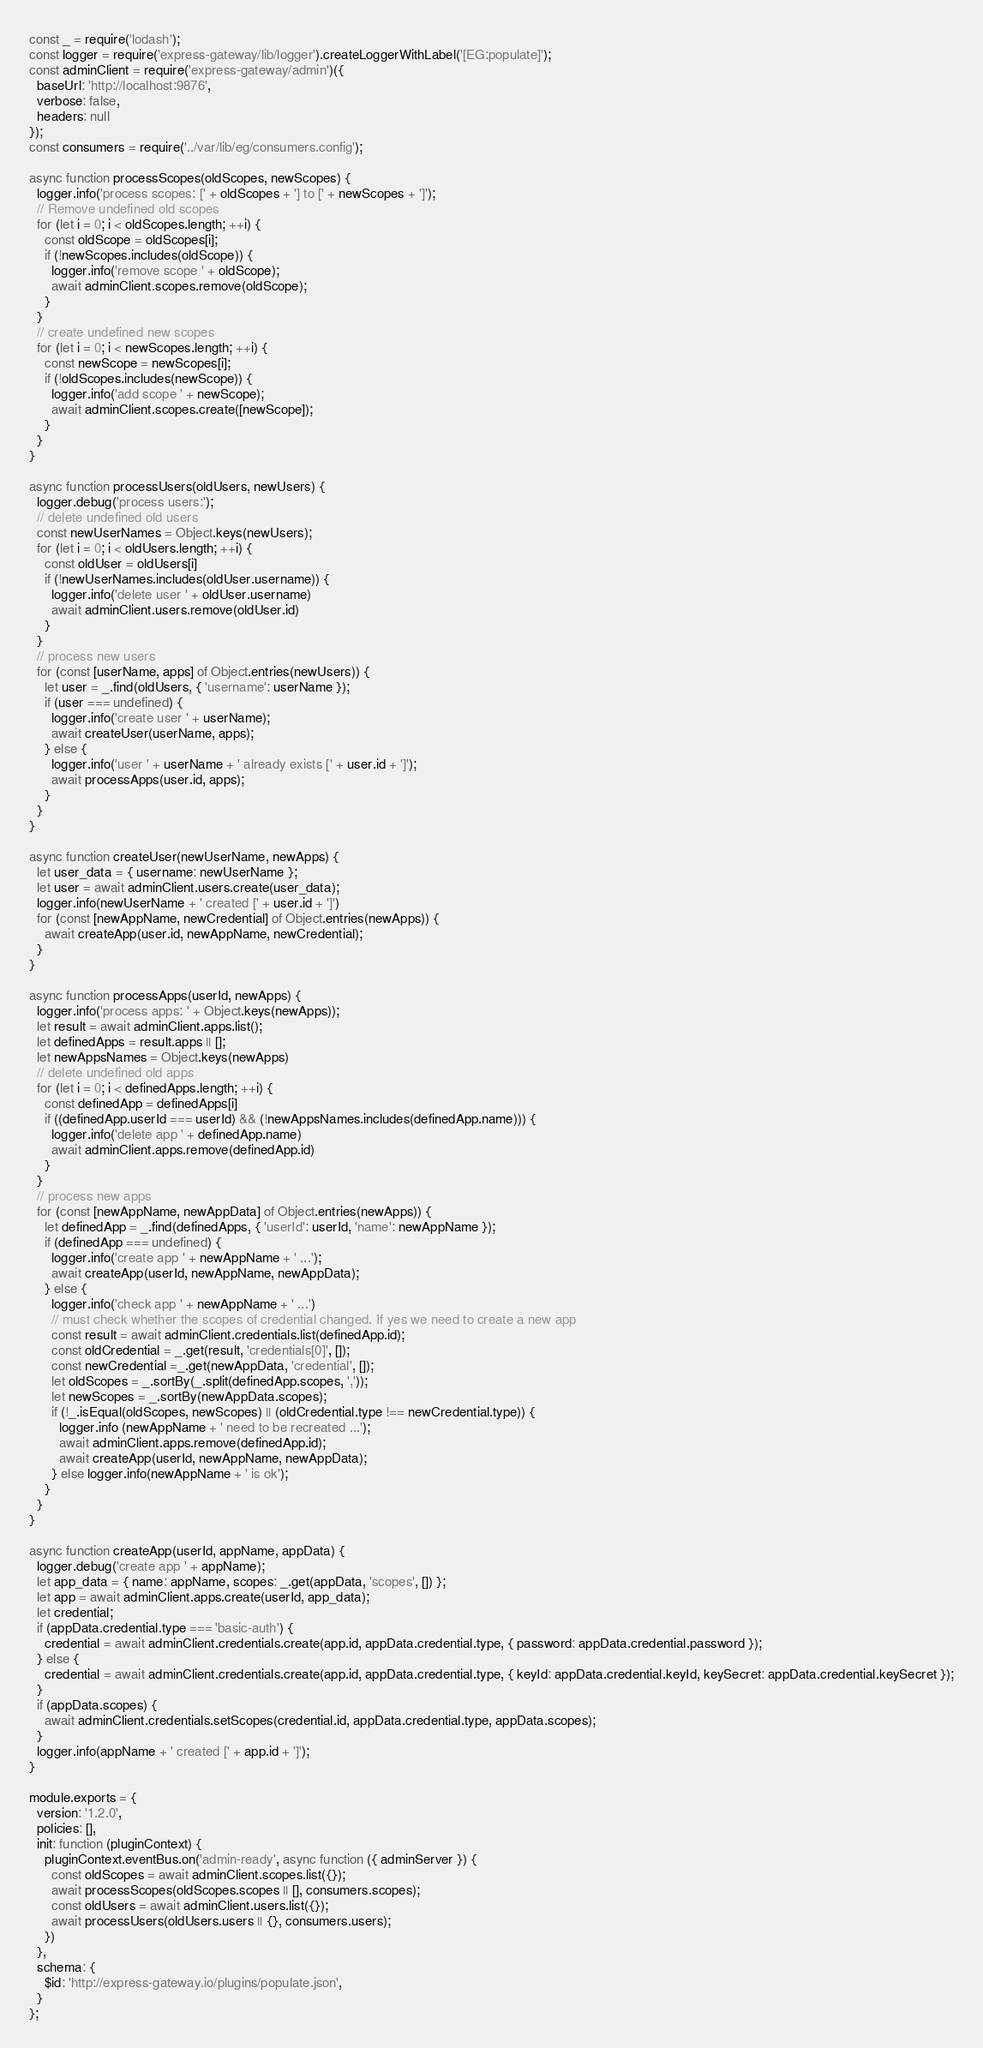<code> <loc_0><loc_0><loc_500><loc_500><_JavaScript_>const _ = require('lodash');
const logger = require('express-gateway/lib/logger').createLoggerWithLabel('[EG:populate]');
const adminClient = require('express-gateway/admin')({
  baseUrl: 'http://localhost:9876',
  verbose: false,
  headers: null
});
const consumers = require('../var/lib/eg/consumers.config');

async function processScopes(oldScopes, newScopes) {
  logger.info('process scopes: [' + oldScopes + '] to [' + newScopes + ']');
  // Remove undefined old scopes
  for (let i = 0; i < oldScopes.length; ++i) {
    const oldScope = oldScopes[i];
    if (!newScopes.includes(oldScope)) {
      logger.info('remove scope ' + oldScope);
      await adminClient.scopes.remove(oldScope);
    }
  }
  // create undefined new scopes
  for (let i = 0; i < newScopes.length; ++i) {
    const newScope = newScopes[i];
    if (!oldScopes.includes(newScope)) {
      logger.info('add scope ' + newScope);
      await adminClient.scopes.create([newScope]);
    }
  }
}

async function processUsers(oldUsers, newUsers) {
  logger.debug('process users:');
  // delete undefined old users
  const newUserNames = Object.keys(newUsers);
  for (let i = 0; i < oldUsers.length; ++i) {
    const oldUser = oldUsers[i]
    if (!newUserNames.includes(oldUser.username)) {
      logger.info('delete user ' + oldUser.username)
      await adminClient.users.remove(oldUser.id)
    }
  }
  // process new users
  for (const [userName, apps] of Object.entries(newUsers)) {
    let user = _.find(oldUsers, { 'username': userName });
    if (user === undefined) {
      logger.info('create user ' + userName);
      await createUser(userName, apps);
    } else {
      logger.info('user ' + userName + ' already exists [' + user.id + ']');
      await processApps(user.id, apps);
    }
  }
}

async function createUser(newUserName, newApps) {
  let user_data = { username: newUserName };
  let user = await adminClient.users.create(user_data);
  logger.info(newUserName + ' created [' + user.id + ']')
  for (const [newAppName, newCredential] of Object.entries(newApps)) {
    await createApp(user.id, newAppName, newCredential);
  }
}

async function processApps(userId, newApps) {
  logger.info('process apps: ' + Object.keys(newApps));
  let result = await adminClient.apps.list();
  let definedApps = result.apps || [];
  let newAppsNames = Object.keys(newApps)
  // delete undefined old apps
  for (let i = 0; i < definedApps.length; ++i) {
    const definedApp = definedApps[i]
    if ((definedApp.userId === userId) && (!newAppsNames.includes(definedApp.name))) {
      logger.info('delete app ' + definedApp.name)
      await adminClient.apps.remove(definedApp.id)
    }
  }
  // process new apps
  for (const [newAppName, newAppData] of Object.entries(newApps)) {
    let definedApp = _.find(definedApps, { 'userId': userId, 'name': newAppName });
    if (definedApp === undefined) {
      logger.info('create app ' + newAppName + ' ...');
      await createApp(userId, newAppName, newAppData);
    } else {
      logger.info('check app ' + newAppName + ' ...')
      // must check whether the scopes of credential changed. If yes we need to create a new app
      const result = await adminClient.credentials.list(definedApp.id); 
      const oldCredential = _.get(result, 'credentials[0]', []);
      const newCredential =_.get(newAppData, 'credential', []);
      let oldScopes = _.sortBy(_.split(definedApp.scopes, ','));
      let newScopes = _.sortBy(newAppData.scopes);
      if (!_.isEqual(oldScopes, newScopes) || (oldCredential.type !== newCredential.type)) {
        logger.info (newAppName + ' need to be recreated ...');
        await adminClient.apps.remove(definedApp.id);
        await createApp(userId, newAppName, newAppData);
      } else logger.info(newAppName + ' is ok');
    }
  }
}

async function createApp(userId, appName, appData) {
  logger.debug('create app ' + appName);
  let app_data = { name: appName, scopes: _.get(appData, 'scopes', []) };
  let app = await adminClient.apps.create(userId, app_data);
  let credential;
  if (appData.credential.type === 'basic-auth') {
    credential = await adminClient.credentials.create(app.id, appData.credential.type, { password: appData.credential.password });
  } else {
    credential = await adminClient.credentials.create(app.id, appData.credential.type, { keyId: appData.credential.keyId, keySecret: appData.credential.keySecret });
  }
  if (appData.scopes) {
    await adminClient.credentials.setScopes(credential.id, appData.credential.type, appData.scopes);
  }
  logger.info(appName + ' created [' + app.id + ']');
}

module.exports = {
  version: '1.2.0',
  policies: [],
  init: function (pluginContext) {
    pluginContext.eventBus.on('admin-ready', async function ({ adminServer }) {
      const oldScopes = await adminClient.scopes.list({});
      await processScopes(oldScopes.scopes || [], consumers.scopes);
      const oldUsers = await adminClient.users.list({});
      await processUsers(oldUsers.users || {}, consumers.users);
    })
  },
  schema: {
    $id: 'http://express-gateway.io/plugins/populate.json',
  }
};
</code> 